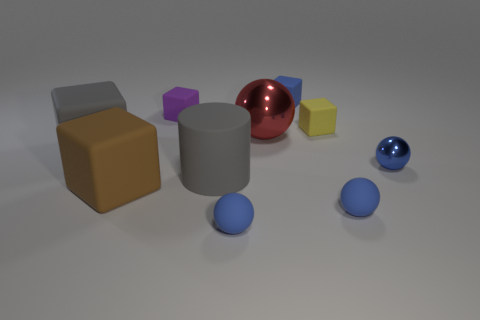How many blue balls must be subtracted to get 1 blue balls? 2 Subtract all blue blocks. How many blue balls are left? 3 Subtract 2 blocks. How many blocks are left? 3 Subtract all yellow blocks. How many blocks are left? 4 Subtract all small blue matte cubes. How many cubes are left? 4 Subtract all green cubes. Subtract all gray spheres. How many cubes are left? 5 Subtract all spheres. How many objects are left? 6 Add 1 blue rubber blocks. How many blue rubber blocks are left? 2 Add 9 small red rubber objects. How many small red rubber objects exist? 9 Subtract 1 yellow cubes. How many objects are left? 9 